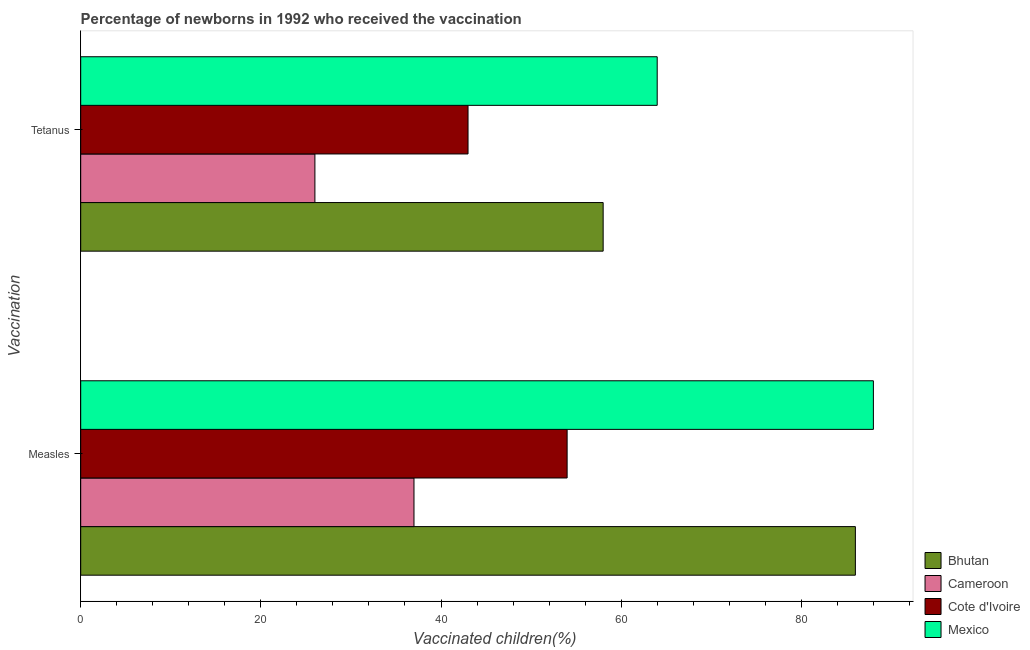Are the number of bars per tick equal to the number of legend labels?
Provide a succinct answer. Yes. Are the number of bars on each tick of the Y-axis equal?
Ensure brevity in your answer.  Yes. What is the label of the 2nd group of bars from the top?
Give a very brief answer. Measles. What is the percentage of newborns who received vaccination for tetanus in Cote d'Ivoire?
Your response must be concise. 43. Across all countries, what is the maximum percentage of newborns who received vaccination for measles?
Keep it short and to the point. 88. Across all countries, what is the minimum percentage of newborns who received vaccination for measles?
Your answer should be compact. 37. In which country was the percentage of newborns who received vaccination for measles minimum?
Your response must be concise. Cameroon. What is the total percentage of newborns who received vaccination for measles in the graph?
Offer a very short reply. 265. What is the difference between the percentage of newborns who received vaccination for tetanus in Cameroon and that in Bhutan?
Ensure brevity in your answer.  -32. What is the difference between the percentage of newborns who received vaccination for measles in Cameroon and the percentage of newborns who received vaccination for tetanus in Bhutan?
Provide a short and direct response. -21. What is the average percentage of newborns who received vaccination for tetanus per country?
Provide a succinct answer. 47.75. What is the difference between the percentage of newborns who received vaccination for tetanus and percentage of newborns who received vaccination for measles in Mexico?
Your answer should be very brief. -24. In how many countries, is the percentage of newborns who received vaccination for tetanus greater than 36 %?
Provide a succinct answer. 3. What is the ratio of the percentage of newborns who received vaccination for measles in Cameroon to that in Cote d'Ivoire?
Keep it short and to the point. 0.69. What does the 1st bar from the top in Measles represents?
Your answer should be compact. Mexico. Are all the bars in the graph horizontal?
Provide a succinct answer. Yes. What is the difference between two consecutive major ticks on the X-axis?
Offer a terse response. 20. Does the graph contain grids?
Your answer should be very brief. No. How many legend labels are there?
Ensure brevity in your answer.  4. How are the legend labels stacked?
Your answer should be very brief. Vertical. What is the title of the graph?
Offer a terse response. Percentage of newborns in 1992 who received the vaccination. Does "Syrian Arab Republic" appear as one of the legend labels in the graph?
Your answer should be compact. No. What is the label or title of the X-axis?
Make the answer very short. Vaccinated children(%)
. What is the label or title of the Y-axis?
Provide a short and direct response. Vaccination. What is the Vaccinated children(%)
 in Bhutan in Measles?
Offer a terse response. 86. What is the Vaccinated children(%)
 in Cameroon in Measles?
Offer a terse response. 37. What is the Vaccinated children(%)
 in Cote d'Ivoire in Measles?
Your response must be concise. 54. What is the Vaccinated children(%)
 of Mexico in Measles?
Offer a terse response. 88. What is the Vaccinated children(%)
 in Mexico in Tetanus?
Ensure brevity in your answer.  64. Across all Vaccination, what is the maximum Vaccinated children(%)
 in Cameroon?
Keep it short and to the point. 37. Across all Vaccination, what is the minimum Vaccinated children(%)
 in Cote d'Ivoire?
Keep it short and to the point. 43. What is the total Vaccinated children(%)
 in Bhutan in the graph?
Make the answer very short. 144. What is the total Vaccinated children(%)
 in Cote d'Ivoire in the graph?
Your response must be concise. 97. What is the total Vaccinated children(%)
 in Mexico in the graph?
Make the answer very short. 152. What is the difference between the Vaccinated children(%)
 of Bhutan in Measles and that in Tetanus?
Keep it short and to the point. 28. What is the difference between the Vaccinated children(%)
 of Cote d'Ivoire in Measles and that in Tetanus?
Give a very brief answer. 11. What is the difference between the Vaccinated children(%)
 of Bhutan in Measles and the Vaccinated children(%)
 of Cameroon in Tetanus?
Provide a short and direct response. 60. What is the difference between the Vaccinated children(%)
 of Bhutan in Measles and the Vaccinated children(%)
 of Mexico in Tetanus?
Ensure brevity in your answer.  22. What is the difference between the Vaccinated children(%)
 of Cote d'Ivoire in Measles and the Vaccinated children(%)
 of Mexico in Tetanus?
Your answer should be compact. -10. What is the average Vaccinated children(%)
 of Cameroon per Vaccination?
Keep it short and to the point. 31.5. What is the average Vaccinated children(%)
 of Cote d'Ivoire per Vaccination?
Offer a terse response. 48.5. What is the average Vaccinated children(%)
 in Mexico per Vaccination?
Make the answer very short. 76. What is the difference between the Vaccinated children(%)
 of Bhutan and Vaccinated children(%)
 of Cameroon in Measles?
Ensure brevity in your answer.  49. What is the difference between the Vaccinated children(%)
 of Cameroon and Vaccinated children(%)
 of Mexico in Measles?
Offer a very short reply. -51. What is the difference between the Vaccinated children(%)
 of Cote d'Ivoire and Vaccinated children(%)
 of Mexico in Measles?
Your answer should be compact. -34. What is the difference between the Vaccinated children(%)
 in Bhutan and Vaccinated children(%)
 in Cameroon in Tetanus?
Offer a terse response. 32. What is the difference between the Vaccinated children(%)
 of Bhutan and Vaccinated children(%)
 of Mexico in Tetanus?
Offer a terse response. -6. What is the difference between the Vaccinated children(%)
 of Cameroon and Vaccinated children(%)
 of Cote d'Ivoire in Tetanus?
Provide a succinct answer. -17. What is the difference between the Vaccinated children(%)
 of Cameroon and Vaccinated children(%)
 of Mexico in Tetanus?
Your answer should be very brief. -38. What is the ratio of the Vaccinated children(%)
 in Bhutan in Measles to that in Tetanus?
Your answer should be compact. 1.48. What is the ratio of the Vaccinated children(%)
 in Cameroon in Measles to that in Tetanus?
Offer a very short reply. 1.42. What is the ratio of the Vaccinated children(%)
 of Cote d'Ivoire in Measles to that in Tetanus?
Keep it short and to the point. 1.26. What is the ratio of the Vaccinated children(%)
 in Mexico in Measles to that in Tetanus?
Give a very brief answer. 1.38. What is the difference between the highest and the second highest Vaccinated children(%)
 in Bhutan?
Offer a very short reply. 28. What is the difference between the highest and the second highest Vaccinated children(%)
 in Cameroon?
Make the answer very short. 11. What is the difference between the highest and the second highest Vaccinated children(%)
 in Cote d'Ivoire?
Your answer should be very brief. 11. What is the difference between the highest and the second highest Vaccinated children(%)
 of Mexico?
Provide a succinct answer. 24. What is the difference between the highest and the lowest Vaccinated children(%)
 of Cameroon?
Your answer should be compact. 11. What is the difference between the highest and the lowest Vaccinated children(%)
 of Cote d'Ivoire?
Provide a short and direct response. 11. 